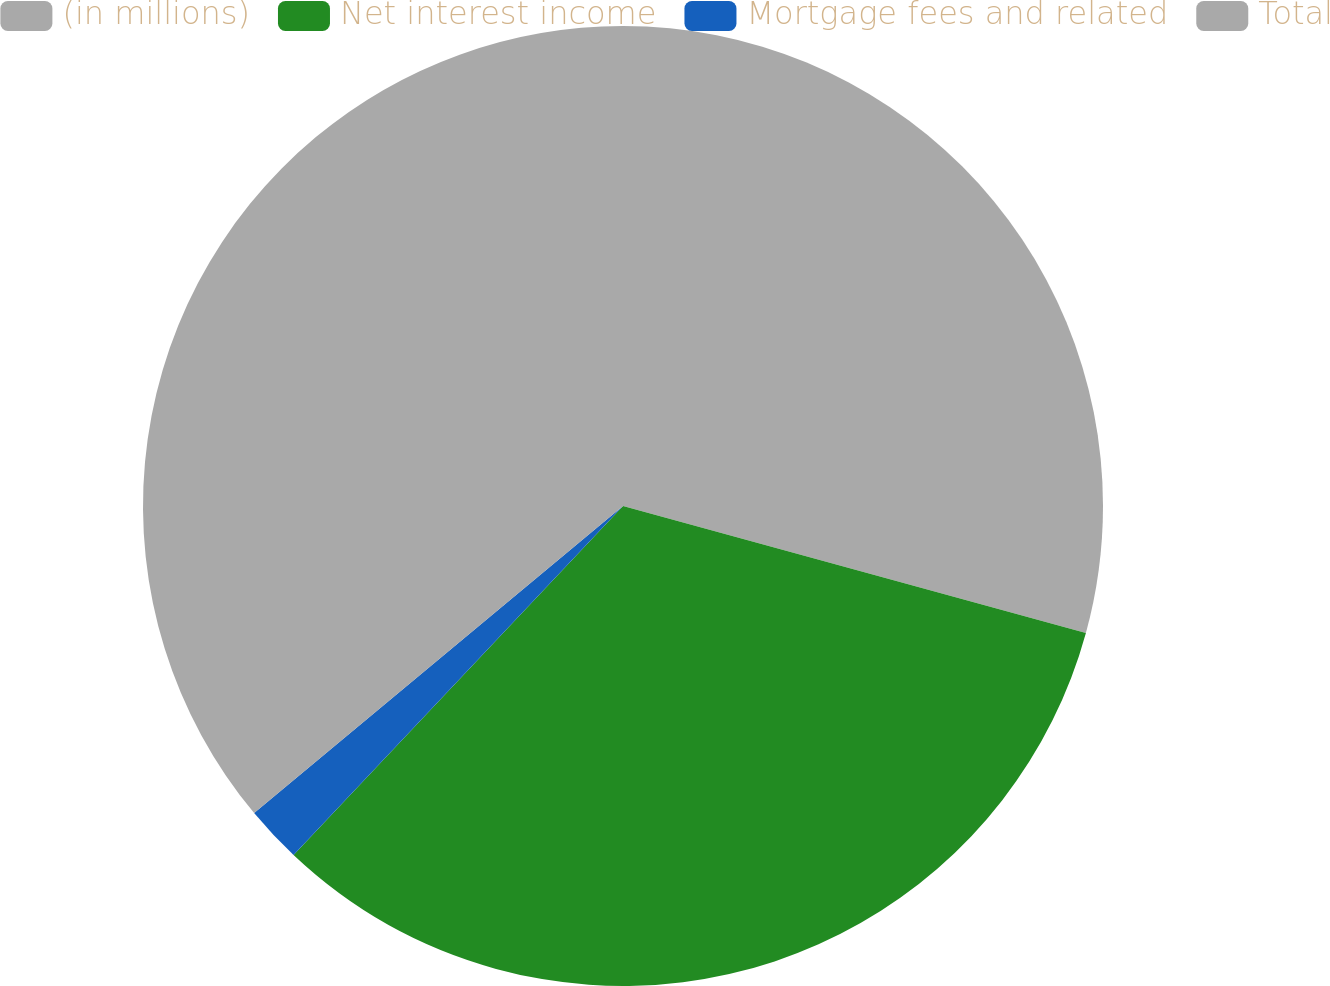<chart> <loc_0><loc_0><loc_500><loc_500><pie_chart><fcel>(in millions)<fcel>Net interest income<fcel>Mortgage fees and related<fcel>Total<nl><fcel>29.26%<fcel>32.78%<fcel>1.91%<fcel>36.05%<nl></chart> 